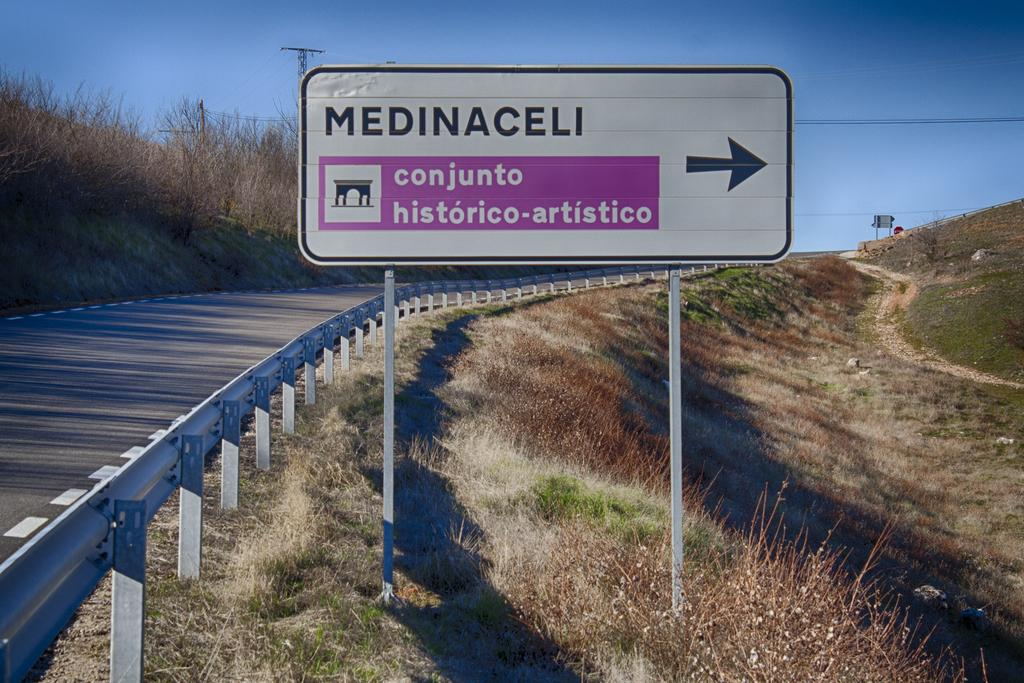Provide a one-sentence caption for the provided image. A rural highway has a white and pink sign that says Medinaceli conjunto historico-artistico. 